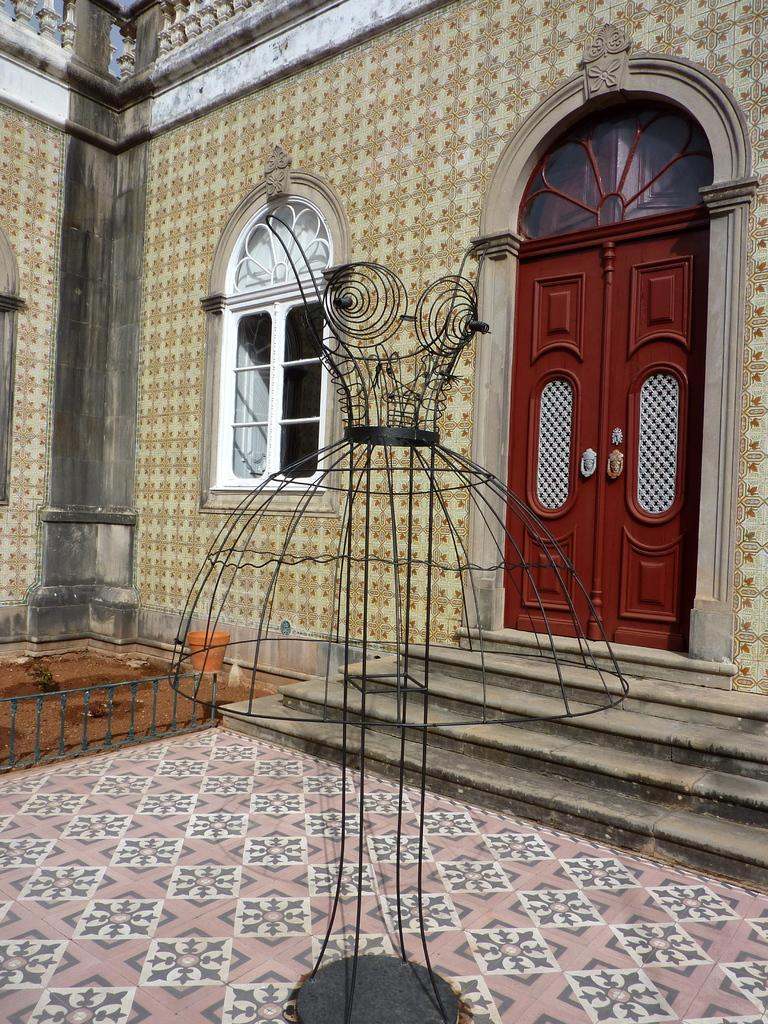What material is the object in the image made of? The object in the image is made up of metal. What can be used to enter or exit a room in the image? There is a door in the image that can be used for entering or exiting a room. What can be used to separate areas in the image? There is a fence in the image that can be used to separate areas. What can be used to see the outside while being indoors in the image? There is a window in the image that can be used to see the outside while being indoors. What can be used to divide spaces in the image? There is a wall in the image that can be used to divide spaces. What can be used to support the weight of people and objects in the image? There is a floor in the image that can be used to support the weight of people and objects. What language is spoken by the wrist in the image? There is no wrist present in the image, and therefore no language can be spoken by it. What decision is being made by the fence in the image? There is no decision-making process associated with the fence in the image; it is simply a barrier separating areas. 